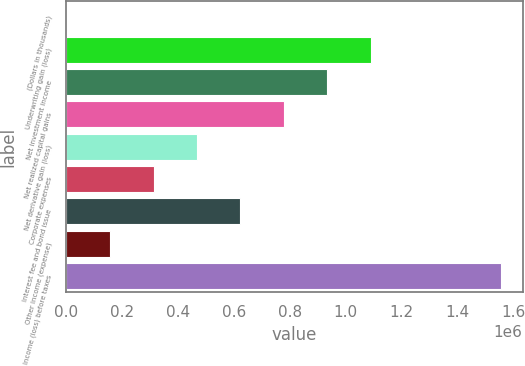Convert chart to OTSL. <chart><loc_0><loc_0><loc_500><loc_500><bar_chart><fcel>(Dollars in thousands)<fcel>Underwriting gain (loss)<fcel>Net investment income<fcel>Net realized capital gains<fcel>Net derivative gain (loss)<fcel>Corporate expenses<fcel>Interest fee and bond issue<fcel>Other income (expense)<fcel>Income (loss) before taxes<nl><fcel>2013<fcel>1.08908e+06<fcel>933785<fcel>778490<fcel>467899<fcel>312604<fcel>623194<fcel>157308<fcel>1.55497e+06<nl></chart> 